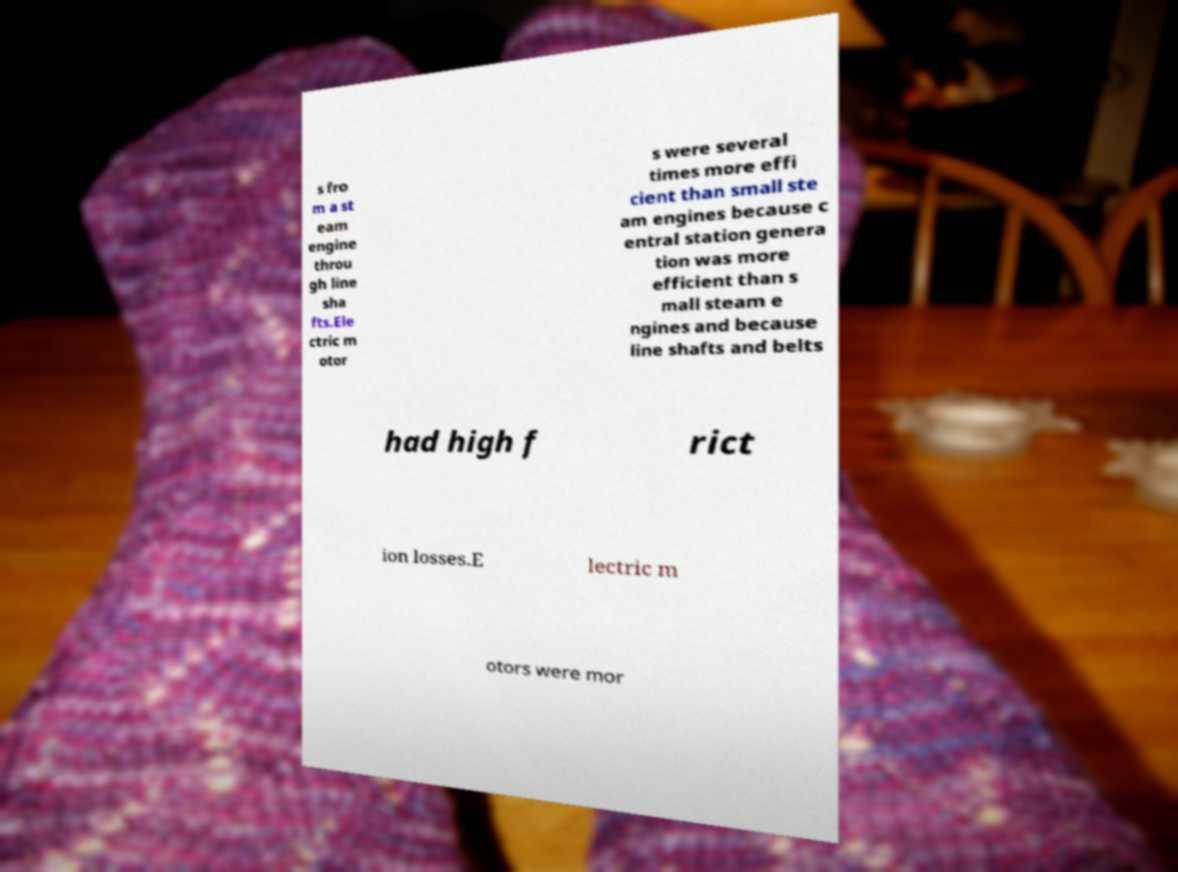Please read and relay the text visible in this image. What does it say? s fro m a st eam engine throu gh line sha fts.Ele ctric m otor s were several times more effi cient than small ste am engines because c entral station genera tion was more efficient than s mall steam e ngines and because line shafts and belts had high f rict ion losses.E lectric m otors were mor 